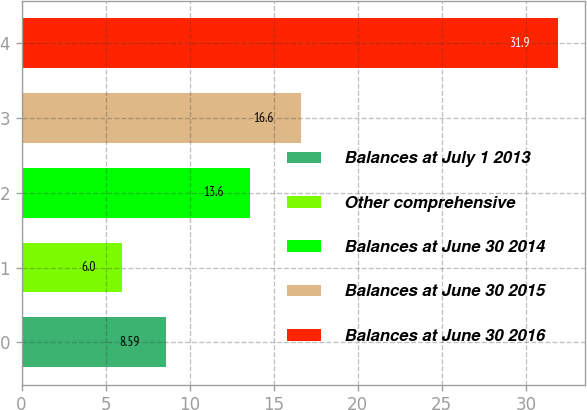Convert chart to OTSL. <chart><loc_0><loc_0><loc_500><loc_500><bar_chart><fcel>Balances at July 1 2013<fcel>Other comprehensive<fcel>Balances at June 30 2014<fcel>Balances at June 30 2015<fcel>Balances at June 30 2016<nl><fcel>8.59<fcel>6<fcel>13.6<fcel>16.6<fcel>31.9<nl></chart> 